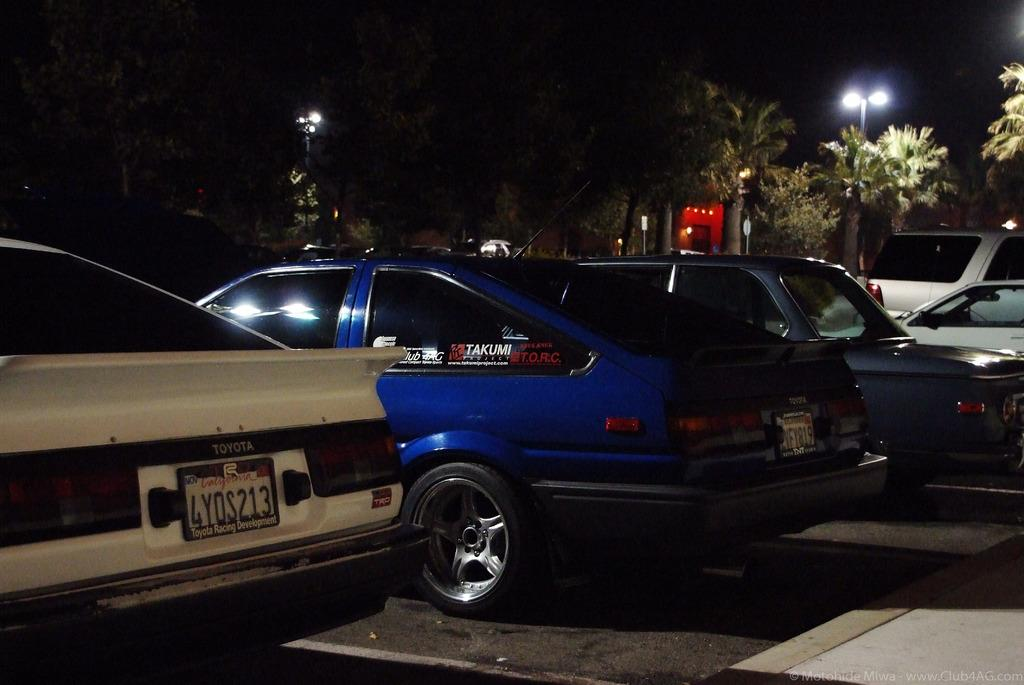What is located in the middle of the image? There are vehicles in the middle of the image. What can be seen behind the vehicles? There are trees and poles behind the vehicles. What type of connection can be seen between the vehicles and the trees in the image? There is no visible connection between the vehicles and the trees in the image. How many carts are present in the image? There is no cart present in the image. 